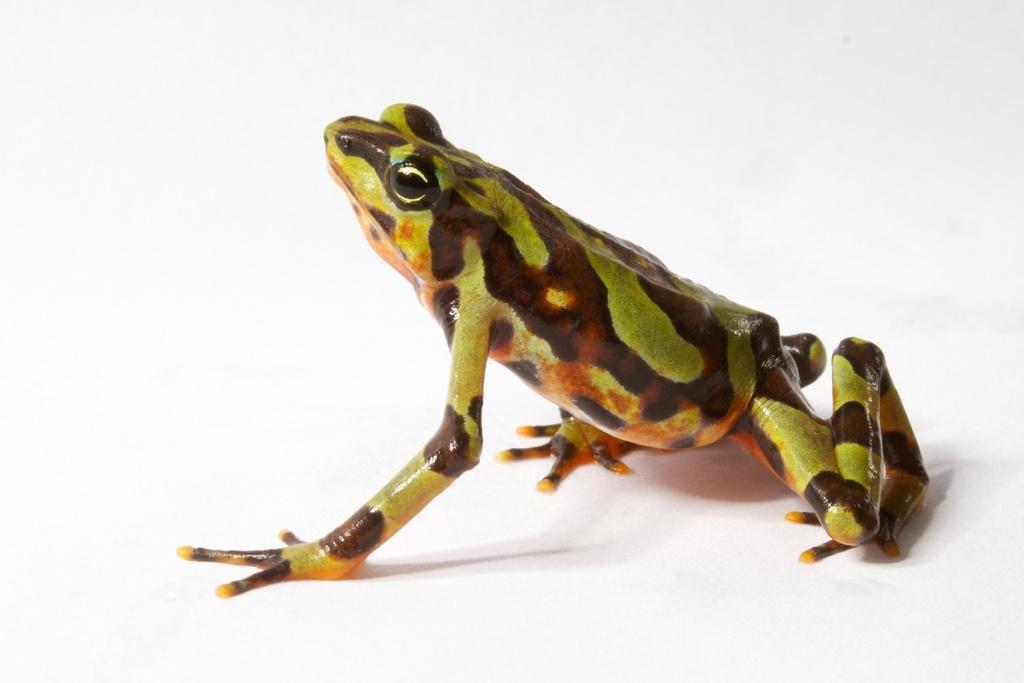Can you describe this image briefly? In this picture we can see a frog on a white surface. 